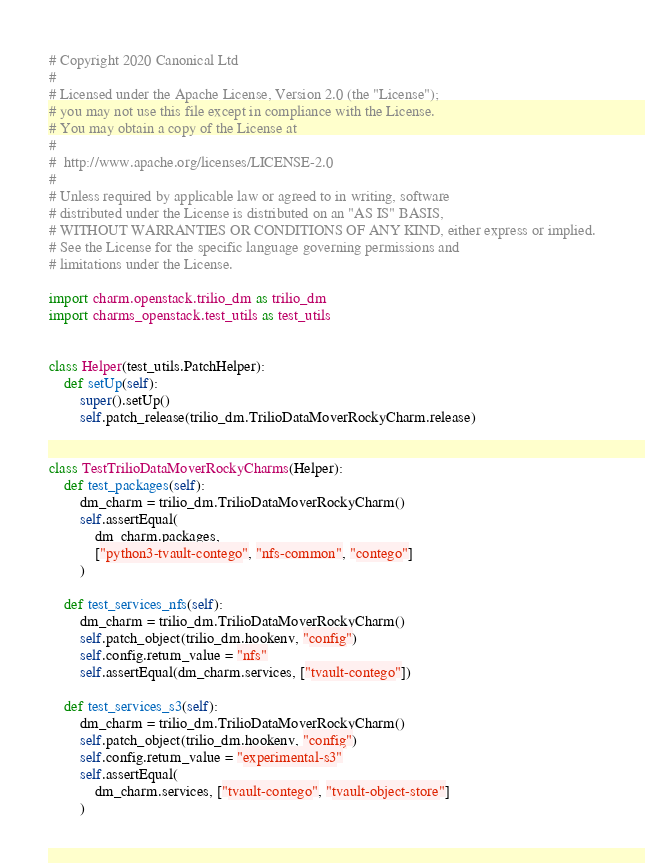<code> <loc_0><loc_0><loc_500><loc_500><_Python_># Copyright 2020 Canonical Ltd
#
# Licensed under the Apache License, Version 2.0 (the "License");
# you may not use this file except in compliance with the License.
# You may obtain a copy of the License at
#
#  http://www.apache.org/licenses/LICENSE-2.0
#
# Unless required by applicable law or agreed to in writing, software
# distributed under the License is distributed on an "AS IS" BASIS,
# WITHOUT WARRANTIES OR CONDITIONS OF ANY KIND, either express or implied.
# See the License for the specific language governing permissions and
# limitations under the License.

import charm.openstack.trilio_dm as trilio_dm
import charms_openstack.test_utils as test_utils


class Helper(test_utils.PatchHelper):
    def setUp(self):
        super().setUp()
        self.patch_release(trilio_dm.TrilioDataMoverRockyCharm.release)


class TestTrilioDataMoverRockyCharms(Helper):
    def test_packages(self):
        dm_charm = trilio_dm.TrilioDataMoverRockyCharm()
        self.assertEqual(
            dm_charm.packages,
            ["python3-tvault-contego", "nfs-common", "contego"]
        )

    def test_services_nfs(self):
        dm_charm = trilio_dm.TrilioDataMoverRockyCharm()
        self.patch_object(trilio_dm.hookenv, "config")
        self.config.return_value = "nfs"
        self.assertEqual(dm_charm.services, ["tvault-contego"])

    def test_services_s3(self):
        dm_charm = trilio_dm.TrilioDataMoverRockyCharm()
        self.patch_object(trilio_dm.hookenv, "config")
        self.config.return_value = "experimental-s3"
        self.assertEqual(
            dm_charm.services, ["tvault-contego", "tvault-object-store"]
        )
</code> 